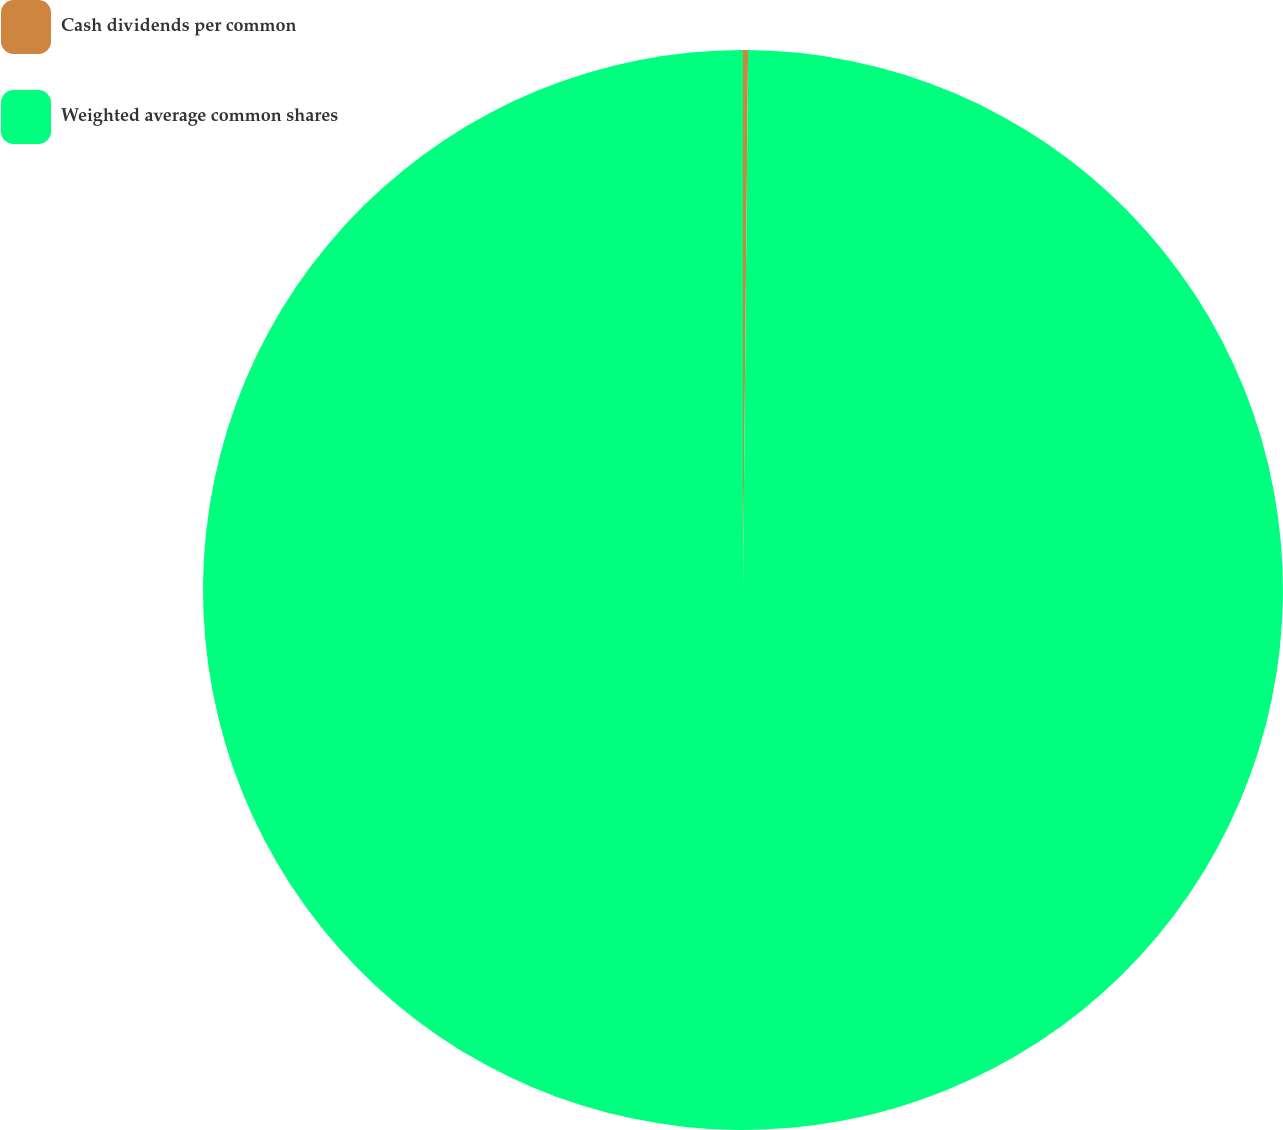<chart> <loc_0><loc_0><loc_500><loc_500><pie_chart><fcel>Cash dividends per common<fcel>Weighted average common shares<nl><fcel>0.15%<fcel>99.85%<nl></chart> 